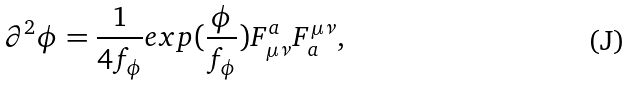<formula> <loc_0><loc_0><loc_500><loc_500>\partial ^ { 2 } \phi = \frac { 1 } { 4 f _ { \phi } } e x p ( \frac { \phi } { f _ { \phi } } ) F _ { \mu \nu } ^ { a } F _ { a } ^ { \mu \nu } ,</formula> 